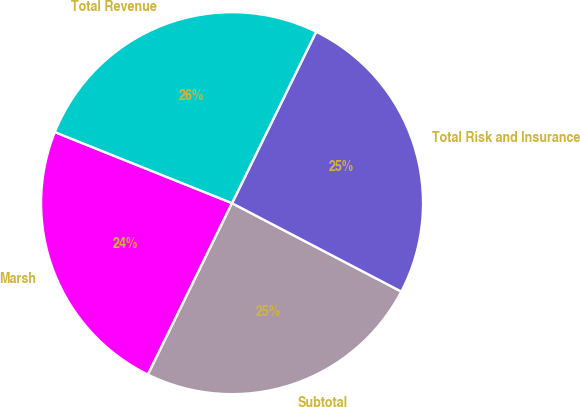<chart> <loc_0><loc_0><loc_500><loc_500><pie_chart><fcel>Marsh<fcel>Subtotal<fcel>Total Risk and Insurance<fcel>Total Revenue<nl><fcel>23.81%<fcel>24.6%<fcel>25.4%<fcel>26.19%<nl></chart> 